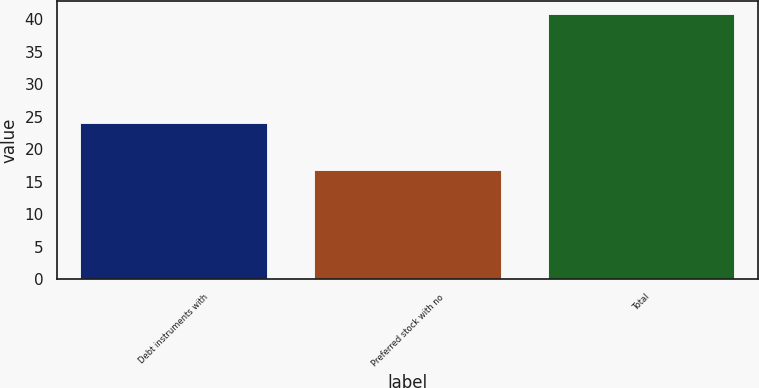Convert chart. <chart><loc_0><loc_0><loc_500><loc_500><bar_chart><fcel>Debt instruments with<fcel>Preferred stock with no<fcel>Total<nl><fcel>24<fcel>16.8<fcel>40.8<nl></chart> 